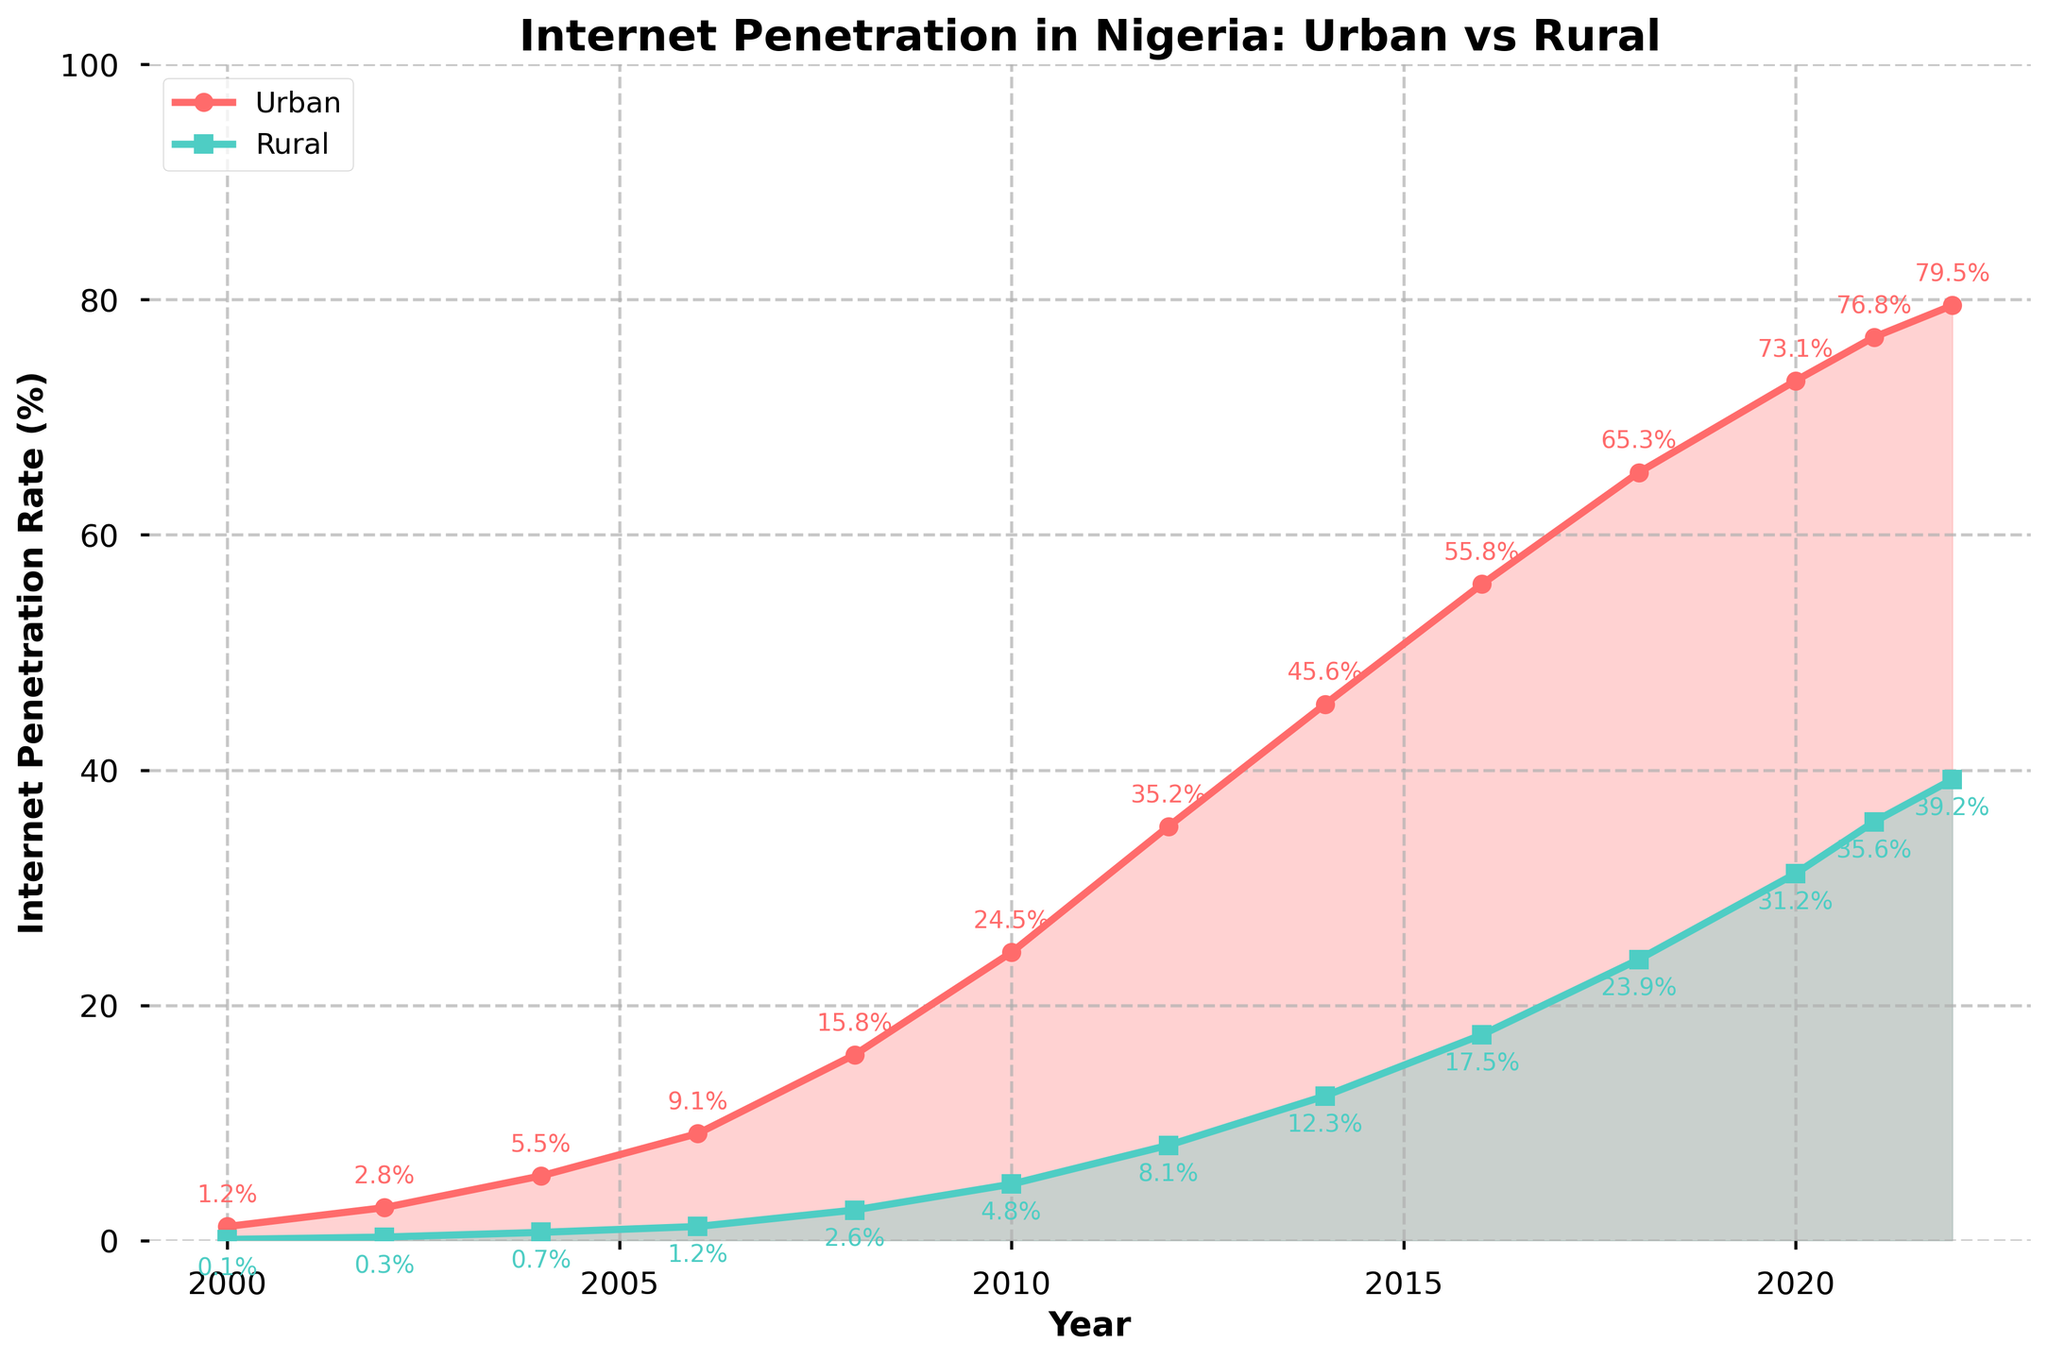what is the year with the lowest urban internet penetration rate? The plot shows that urban internet penetration increases over time. The year with the lowest urban internet penetration is the starting point. According to the chart, in 2000, urban internet penetration was 1.2%, which is the lowest value.
Answer: 2000 what is the increase in rural internet penetration from 2002 to 2004? Looking at the plot, in 2002, rural internet penetration was 0.3%. In 2004, it increased to 0.7%. The increase is 0.7% - 0.3% = 0.4%.
Answer: 0.4% what's the average urban internet penetration rate from 2010 to 2014? The urban internet penetration rates for 2010, 2012, and 2014 are 24.5%, 35.2%, and 45.6%, respectively. Adding them: 24.5% + 35.2% + 45.6% = 105.3%. Dividing by 3 (number of years): 105.3% / 3 = 35.1%.
Answer: 35.1% which year had a larger difference between urban and rural internet penetration rates: 2016 or 2022? For 2016, urban penetration was 55.8% and rural was 17.5%, leading to a difference of 55.8% - 17.5% = 38.3%. For 2022, urban penetration was 79.5% and rural was 39.2%, leading to a difference of 79.5% - 39.2% = 40.3%. Therefore, 2022 had a larger difference.
Answer: 2022 what is the color used to represent rural penetration in the chart? The plot shows rural internet penetration with a line and shaded area in turquoise (or light blue-green).
Answer: turquoise in which year did both urban and rural internet penetration rates first exceed 10%? According to the chart, urban penetration exceeded 10% in 2006, but rural penetration first exceeded 10% in 2014, where rural penetration was 12.3%.
Answer: 2014 compare the growth rate of urban internet penetration between 2008 and 2010 to the growth rate between 2020 and 2022? From 2008 to 2010, urban grew from 15.8% to 24.5%, a difference of 24.5% - 15.8% = 8.7%. From 2020 to 2022, urban grew from 73.1% to 79.5%, a difference of 79.5% - 73.1% = 6.4%. The growth rate between 2008 and 2010 (8.7%) was higher than between 2020 and 2022 (6.4%).
Answer: 2008-2010 what was the total increase in rural internet penetration from 2000 to 2022? According to the chart, rural penetration in 2000 was 0.1% and in 2022 it was 39.2%. The total increase is 39.2% - 0.1% = 39.1%.
Answer: 39.1% what can we say about the trend in internet penetration in urban versus rural areas over time? The plot indicates a consistent increase in both urban and rural internet penetration over time. Urban areas show a higher penetration rate throughout and a sharper upward trend, especially after 2012. Meanwhile, rural areas also show growth but at a slower and more gradual pace.
Answer: consistent increase, faster in urban areas which year shows the highest combined internet penetration rate for urban and rural areas? To find this, sum the rates for each year and find the maximum. In 2022: 79.5% (urban) + 39.2% (rural) = 118.7%, which is the highest combined rate compared to other years.
Answer: 2022 